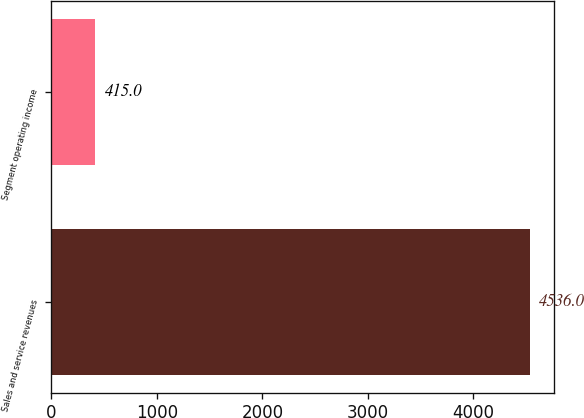Convert chart to OTSL. <chart><loc_0><loc_0><loc_500><loc_500><bar_chart><fcel>Sales and service revenues<fcel>Segment operating income<nl><fcel>4536<fcel>415<nl></chart> 